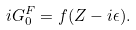<formula> <loc_0><loc_0><loc_500><loc_500>i G ^ { F } _ { 0 } = f ( Z - i \epsilon ) .</formula> 